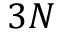Convert formula to latex. <formula><loc_0><loc_0><loc_500><loc_500>3 N</formula> 